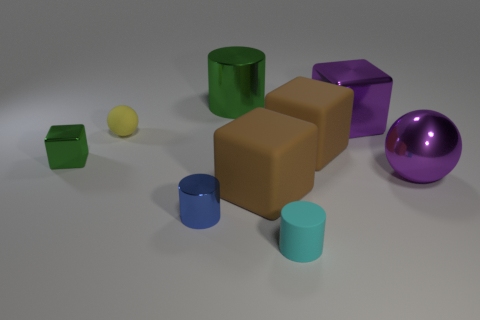Is the material of the tiny green thing in front of the tiny matte sphere the same as the tiny thing that is to the right of the big green object?
Give a very brief answer. No. How many blocks are tiny shiny objects or purple things?
Offer a very short reply. 2. There is a large brown rubber thing behind the block that is to the left of the green cylinder; how many small cyan matte cylinders are behind it?
Make the answer very short. 0. There is another large object that is the same shape as the blue thing; what is it made of?
Your answer should be compact. Metal. Is there any other thing that has the same material as the small green block?
Keep it short and to the point. Yes. There is a big shiny thing that is left of the cyan cylinder; what color is it?
Offer a terse response. Green. Does the blue cylinder have the same material as the ball that is right of the blue metal cylinder?
Offer a terse response. Yes. What is the material of the purple ball?
Your answer should be compact. Metal. There is a small blue object that is made of the same material as the small green thing; what shape is it?
Make the answer very short. Cylinder. What number of other things are there of the same shape as the tiny green shiny object?
Keep it short and to the point. 3. 